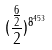Convert formula to latex. <formula><loc_0><loc_0><loc_500><loc_500>( \frac { \frac { 6 } { 2 } } { 2 } ) ^ { 8 ^ { 4 5 3 } }</formula> 